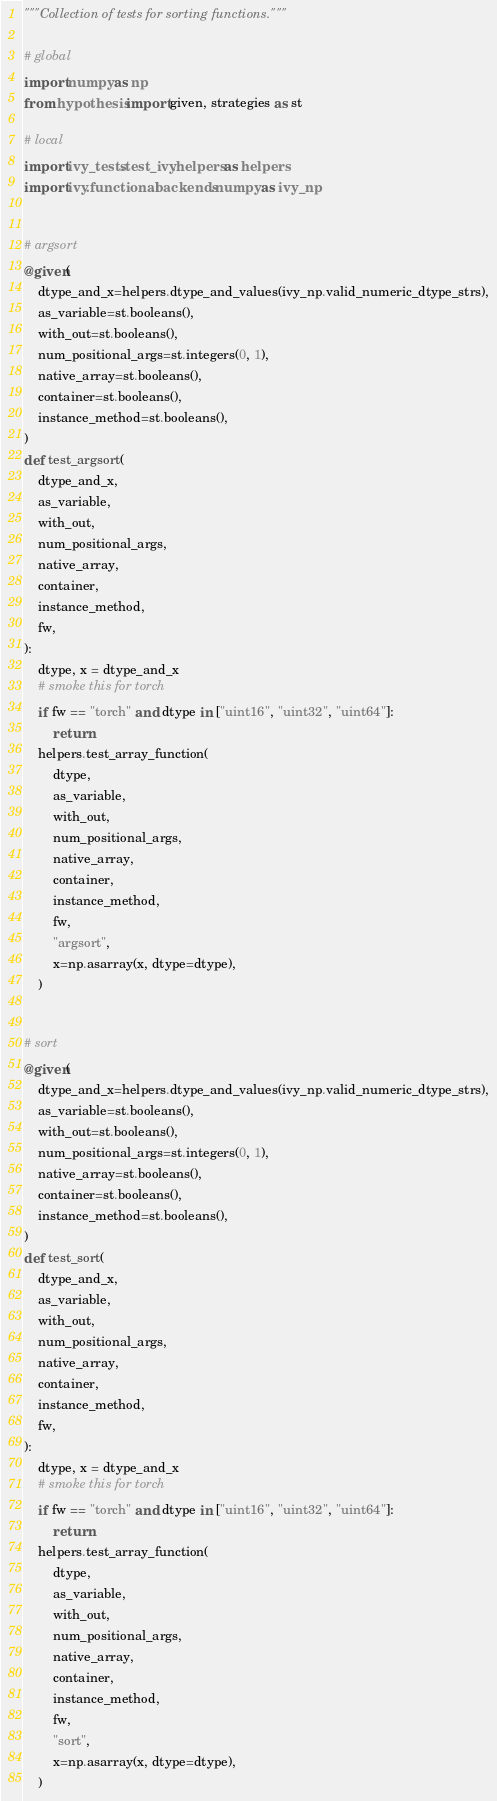<code> <loc_0><loc_0><loc_500><loc_500><_Python_>"""Collection of tests for sorting functions."""

# global
import numpy as np
from hypothesis import given, strategies as st

# local
import ivy_tests.test_ivy.helpers as helpers
import ivy.functional.backends.numpy as ivy_np


# argsort
@given(
    dtype_and_x=helpers.dtype_and_values(ivy_np.valid_numeric_dtype_strs),
    as_variable=st.booleans(),
    with_out=st.booleans(),
    num_positional_args=st.integers(0, 1),
    native_array=st.booleans(),
    container=st.booleans(),
    instance_method=st.booleans(),
)
def test_argsort(
    dtype_and_x,
    as_variable,
    with_out,
    num_positional_args,
    native_array,
    container,
    instance_method,
    fw,
):
    dtype, x = dtype_and_x
    # smoke this for torch
    if fw == "torch" and dtype in ["uint16", "uint32", "uint64"]:
        return
    helpers.test_array_function(
        dtype,
        as_variable,
        with_out,
        num_positional_args,
        native_array,
        container,
        instance_method,
        fw,
        "argsort",
        x=np.asarray(x, dtype=dtype),
    )


# sort
@given(
    dtype_and_x=helpers.dtype_and_values(ivy_np.valid_numeric_dtype_strs),
    as_variable=st.booleans(),
    with_out=st.booleans(),
    num_positional_args=st.integers(0, 1),
    native_array=st.booleans(),
    container=st.booleans(),
    instance_method=st.booleans(),
)
def test_sort(
    dtype_and_x,
    as_variable,
    with_out,
    num_positional_args,
    native_array,
    container,
    instance_method,
    fw,
):
    dtype, x = dtype_and_x
    # smoke this for torch
    if fw == "torch" and dtype in ["uint16", "uint32", "uint64"]:
        return
    helpers.test_array_function(
        dtype,
        as_variable,
        with_out,
        num_positional_args,
        native_array,
        container,
        instance_method,
        fw,
        "sort",
        x=np.asarray(x, dtype=dtype),
    )
</code> 